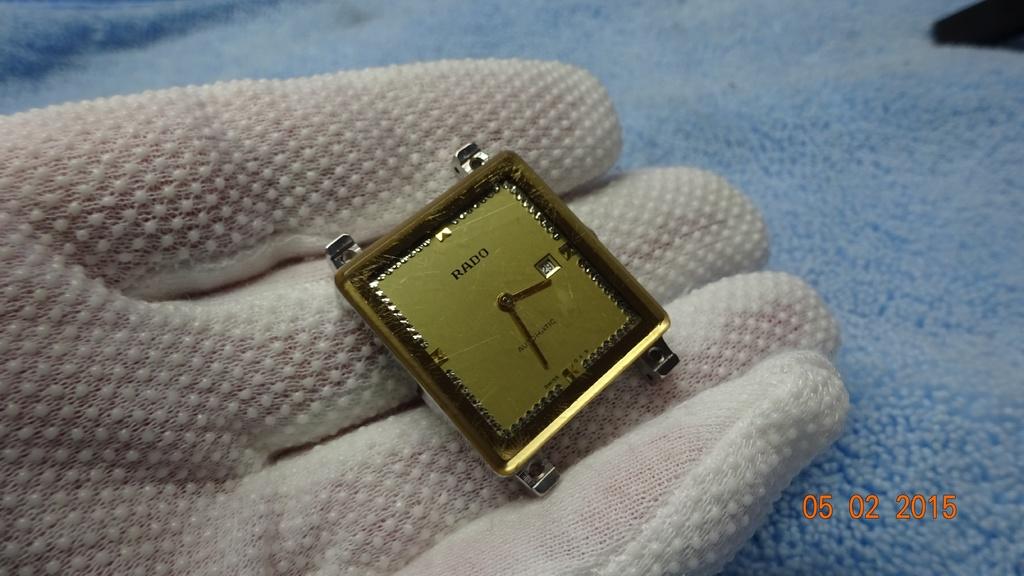What brand is the watch?
Provide a short and direct response. Rado. What year was this photo taken?
Offer a terse response. 2015. 